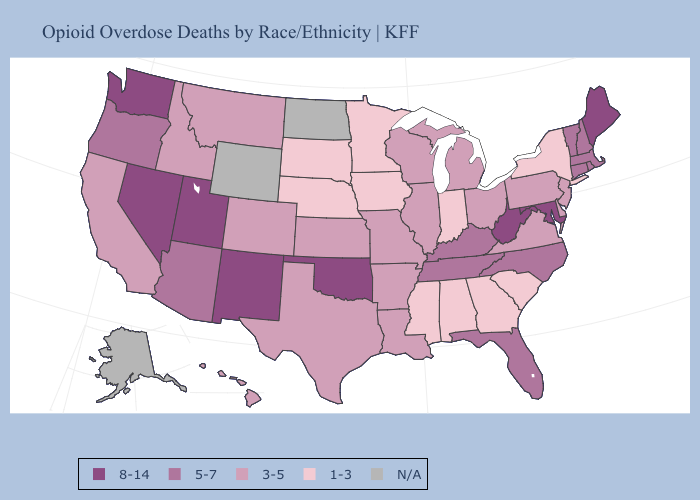Among the states that border Rhode Island , which have the lowest value?
Concise answer only. Connecticut, Massachusetts. Does South Carolina have the lowest value in the South?
Keep it brief. Yes. Does West Virginia have the lowest value in the South?
Quick response, please. No. What is the value of Massachusetts?
Be succinct. 5-7. Name the states that have a value in the range 5-7?
Answer briefly. Arizona, Connecticut, Florida, Kentucky, Massachusetts, New Hampshire, North Carolina, Oregon, Rhode Island, Tennessee, Vermont. What is the value of California?
Keep it brief. 3-5. What is the value of Florida?
Be succinct. 5-7. How many symbols are there in the legend?
Write a very short answer. 5. What is the value of Wyoming?
Concise answer only. N/A. Name the states that have a value in the range 1-3?
Concise answer only. Alabama, Georgia, Indiana, Iowa, Minnesota, Mississippi, Nebraska, New York, South Carolina, South Dakota. What is the highest value in the USA?
Quick response, please. 8-14. What is the value of Massachusetts?
Keep it brief. 5-7. 